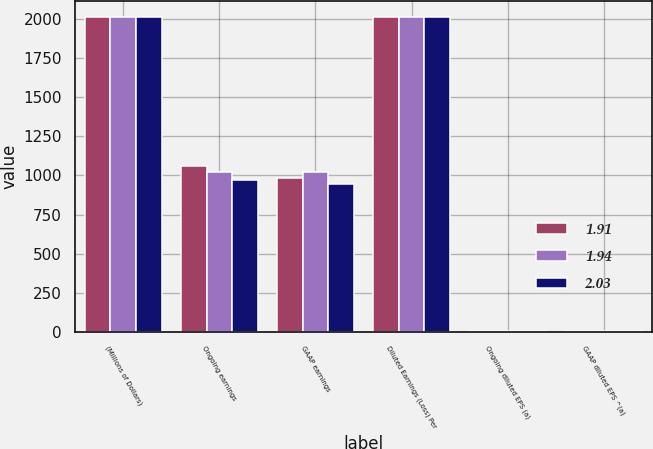Convert chart to OTSL. <chart><loc_0><loc_0><loc_500><loc_500><stacked_bar_chart><ecel><fcel>(Millions of Dollars)<fcel>Ongoing earnings<fcel>GAAP earnings<fcel>Diluted Earnings (Loss) Per<fcel>Ongoing diluted EPS (a)<fcel>GAAP diluted EPS ^(a)<nl><fcel>1.91<fcel>2015<fcel>1063.7<fcel>984.5<fcel>2015<fcel>2.09<fcel>1.94<nl><fcel>1.94<fcel>2014<fcel>1021.3<fcel>1021.3<fcel>2014<fcel>2.03<fcel>2.03<nl><fcel>2.03<fcel>2013<fcel>968.4<fcel>948.2<fcel>2013<fcel>1.95<fcel>1.91<nl></chart> 